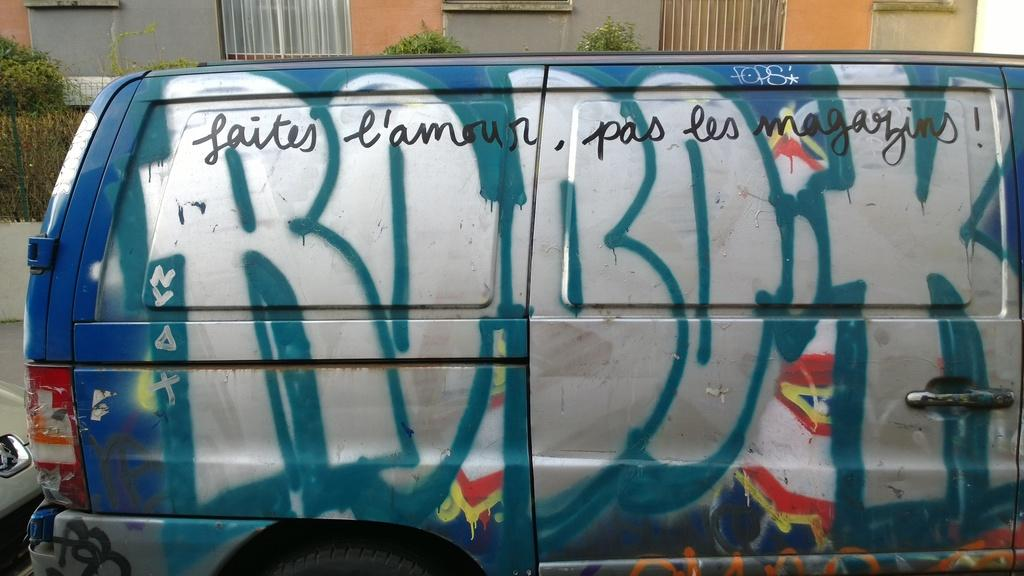Provide a one-sentence caption for the provided image. A truck with graffiti written on it says ROBOK. 